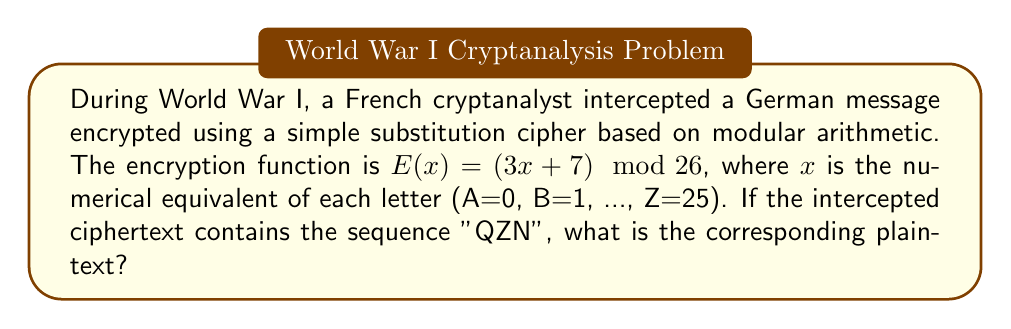Can you answer this question? To solve this problem, we need to use the decryption function, which is the inverse of the encryption function. Let's approach this step-by-step:

1) The encryption function is $E(x) = (3x + 7) \mod 26$

2) To find the decryption function $D(y)$, we need to solve the congruence:
   $y \equiv 3x + 7 \pmod{26}$

3) Subtracting 7 from both sides:
   $y - 7 \equiv 3x \pmod{26}$

4) Multiplying both sides by the modular multiplicative inverse of 3 (mod 26):
   $3^{-1} \equiv 9 \pmod{26}$ (since $3 \cdot 9 = 27 \equiv 1 \pmod{26}$)

   $9(y - 7) \equiv x \pmod{26}$

5) Therefore, the decryption function is:
   $D(y) = (9(y - 7)) \mod 26$

6) Now, let's decrypt each letter:
   For Q (16): $D(16) = (9(16 - 7)) \mod 26 = 81 \mod 26 = 3 = \text{D}$
   For Z (25): $D(25) = (9(25 - 7)) \mod 26 = 162 \mod 26 = 6 = \text{G}$
   For N (13): $D(13) = (9(13 - 7)) \mod 26 = 54 \mod 26 = 2 = \text{C}$

Therefore, the plaintext corresponding to "QZN" is "DGC".
Answer: DGC 